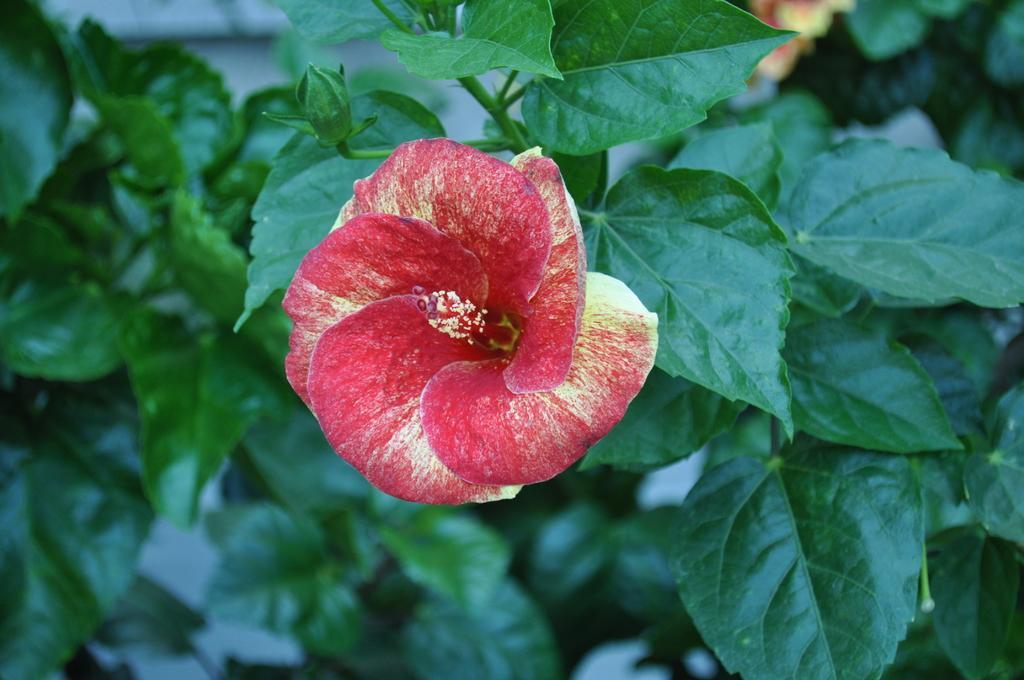Can you describe this image briefly? In this picture I can see there is a shoe flower and there are few leaves and the backdrop is blurred. 